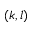Convert formula to latex. <formula><loc_0><loc_0><loc_500><loc_500>( k , l )</formula> 